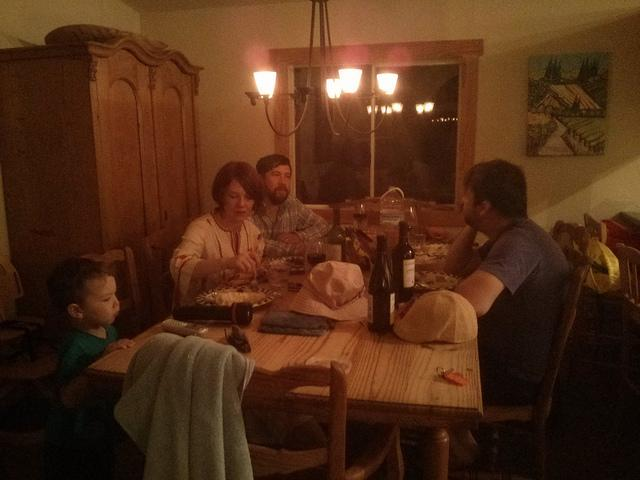Where are these people gathered? dinner 